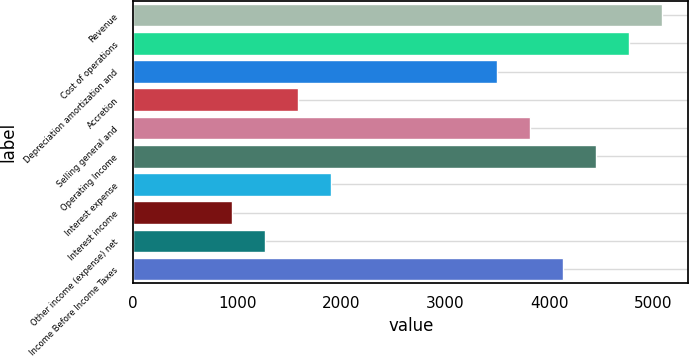Convert chart. <chart><loc_0><loc_0><loc_500><loc_500><bar_chart><fcel>Revenue<fcel>Cost of operations<fcel>Depreciation amortization and<fcel>Accretion<fcel>Selling general and<fcel>Operating Income<fcel>Interest expense<fcel>Interest income<fcel>Other income (expense) net<fcel>Income Before Income Taxes<nl><fcel>5081.57<fcel>4764.01<fcel>3493.76<fcel>1588.38<fcel>3811.33<fcel>4446.45<fcel>1905.95<fcel>953.24<fcel>1270.81<fcel>4128.89<nl></chart> 